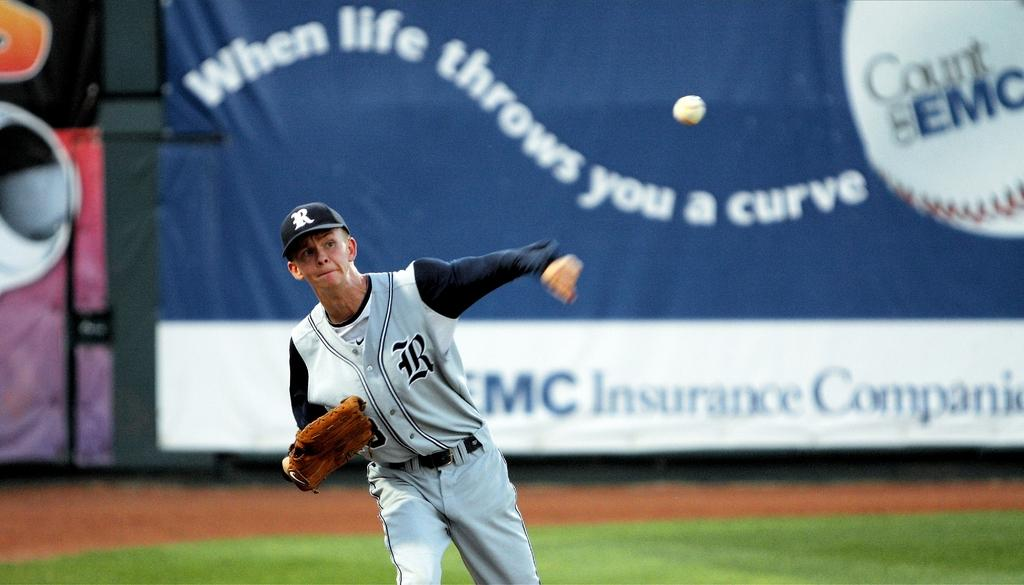<image>
Write a terse but informative summary of the picture. A baseball player, whose hat is adorned with the letter R, throws a ball. 